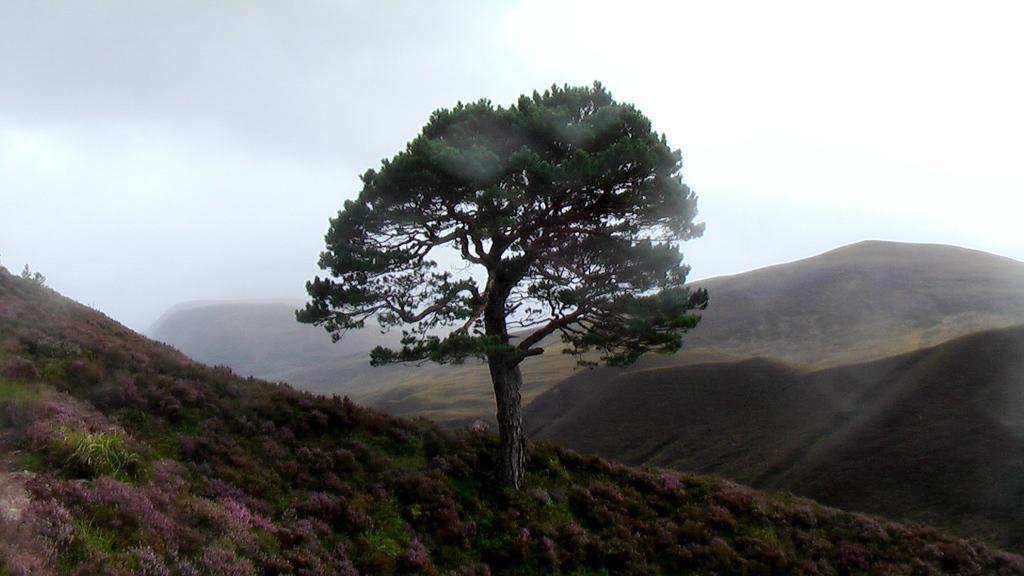Please provide a concise description of this image. There are plants and a tree in the foreground area of the image. There are mountains and the sky in the background. 